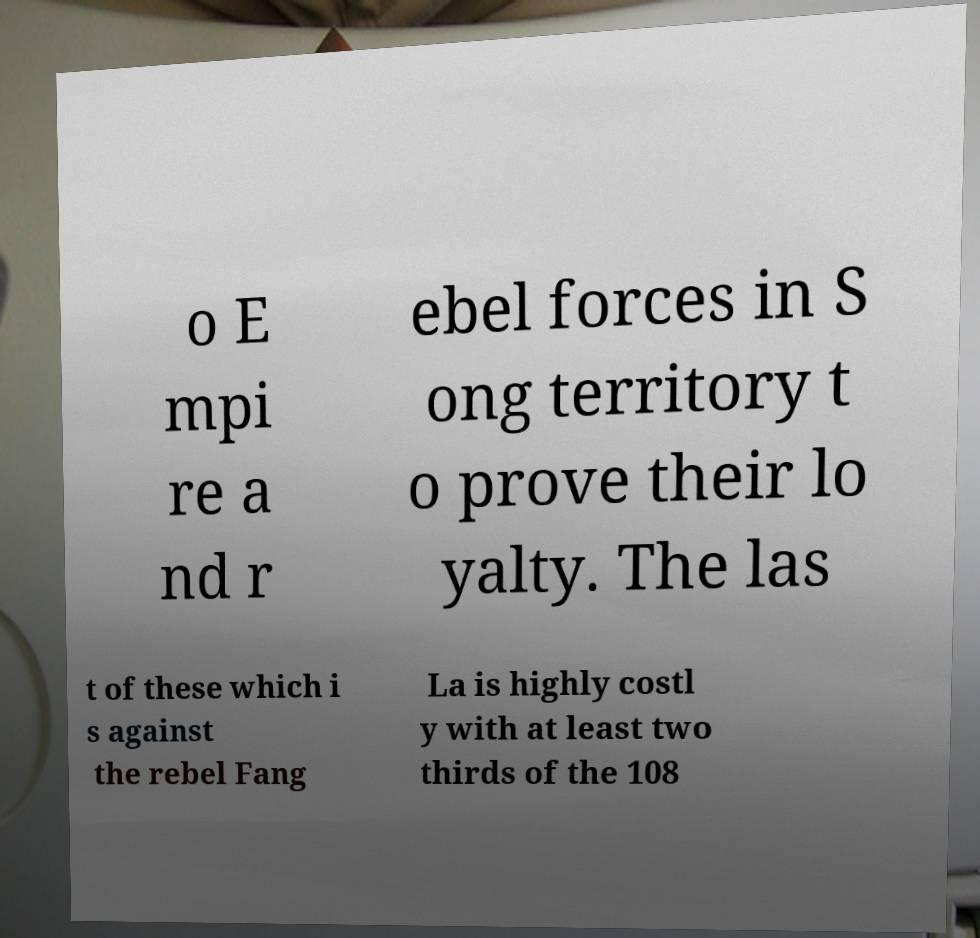I need the written content from this picture converted into text. Can you do that? o E mpi re a nd r ebel forces in S ong territory t o prove their lo yalty. The las t of these which i s against the rebel Fang La is highly costl y with at least two thirds of the 108 